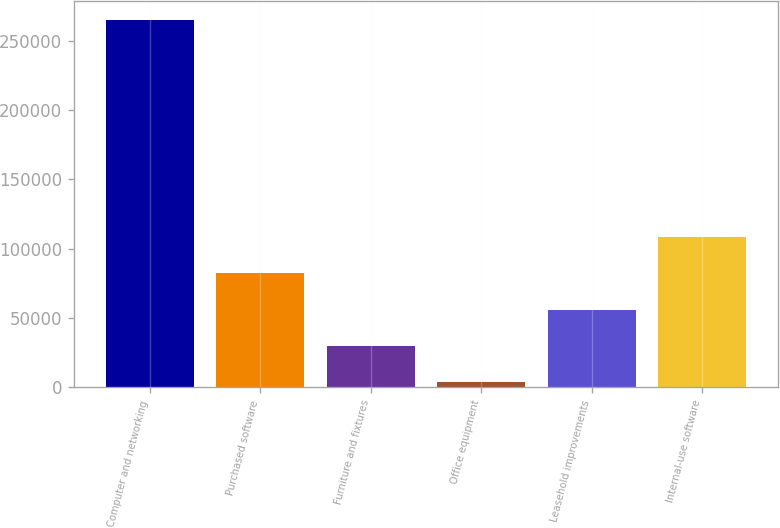Convert chart. <chart><loc_0><loc_0><loc_500><loc_500><bar_chart><fcel>Computer and networking<fcel>Purchased software<fcel>Furniture and fixtures<fcel>Office equipment<fcel>Leasehold improvements<fcel>Internal-use software<nl><fcel>264949<fcel>82193.7<fcel>29977.9<fcel>3870<fcel>56085.8<fcel>108302<nl></chart> 